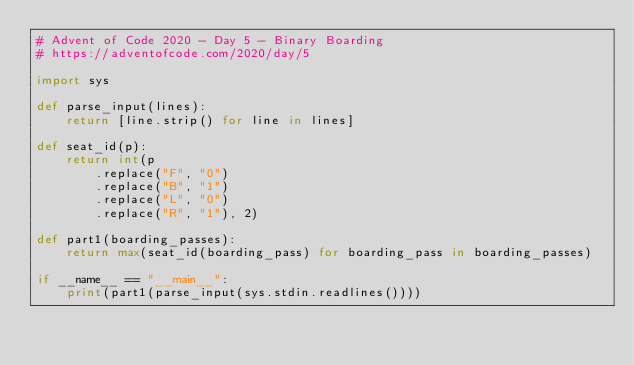<code> <loc_0><loc_0><loc_500><loc_500><_Python_># Advent of Code 2020 - Day 5 - Binary Boarding
# https://adventofcode.com/2020/day/5

import sys

def parse_input(lines):
    return [line.strip() for line in lines]

def seat_id(p):
    return int(p
        .replace("F", "0")
        .replace("B", "1")
        .replace("L", "0")
        .replace("R", "1"), 2)

def part1(boarding_passes):
    return max(seat_id(boarding_pass) for boarding_pass in boarding_passes)

if __name__ == "__main__":
    print(part1(parse_input(sys.stdin.readlines())))
</code> 